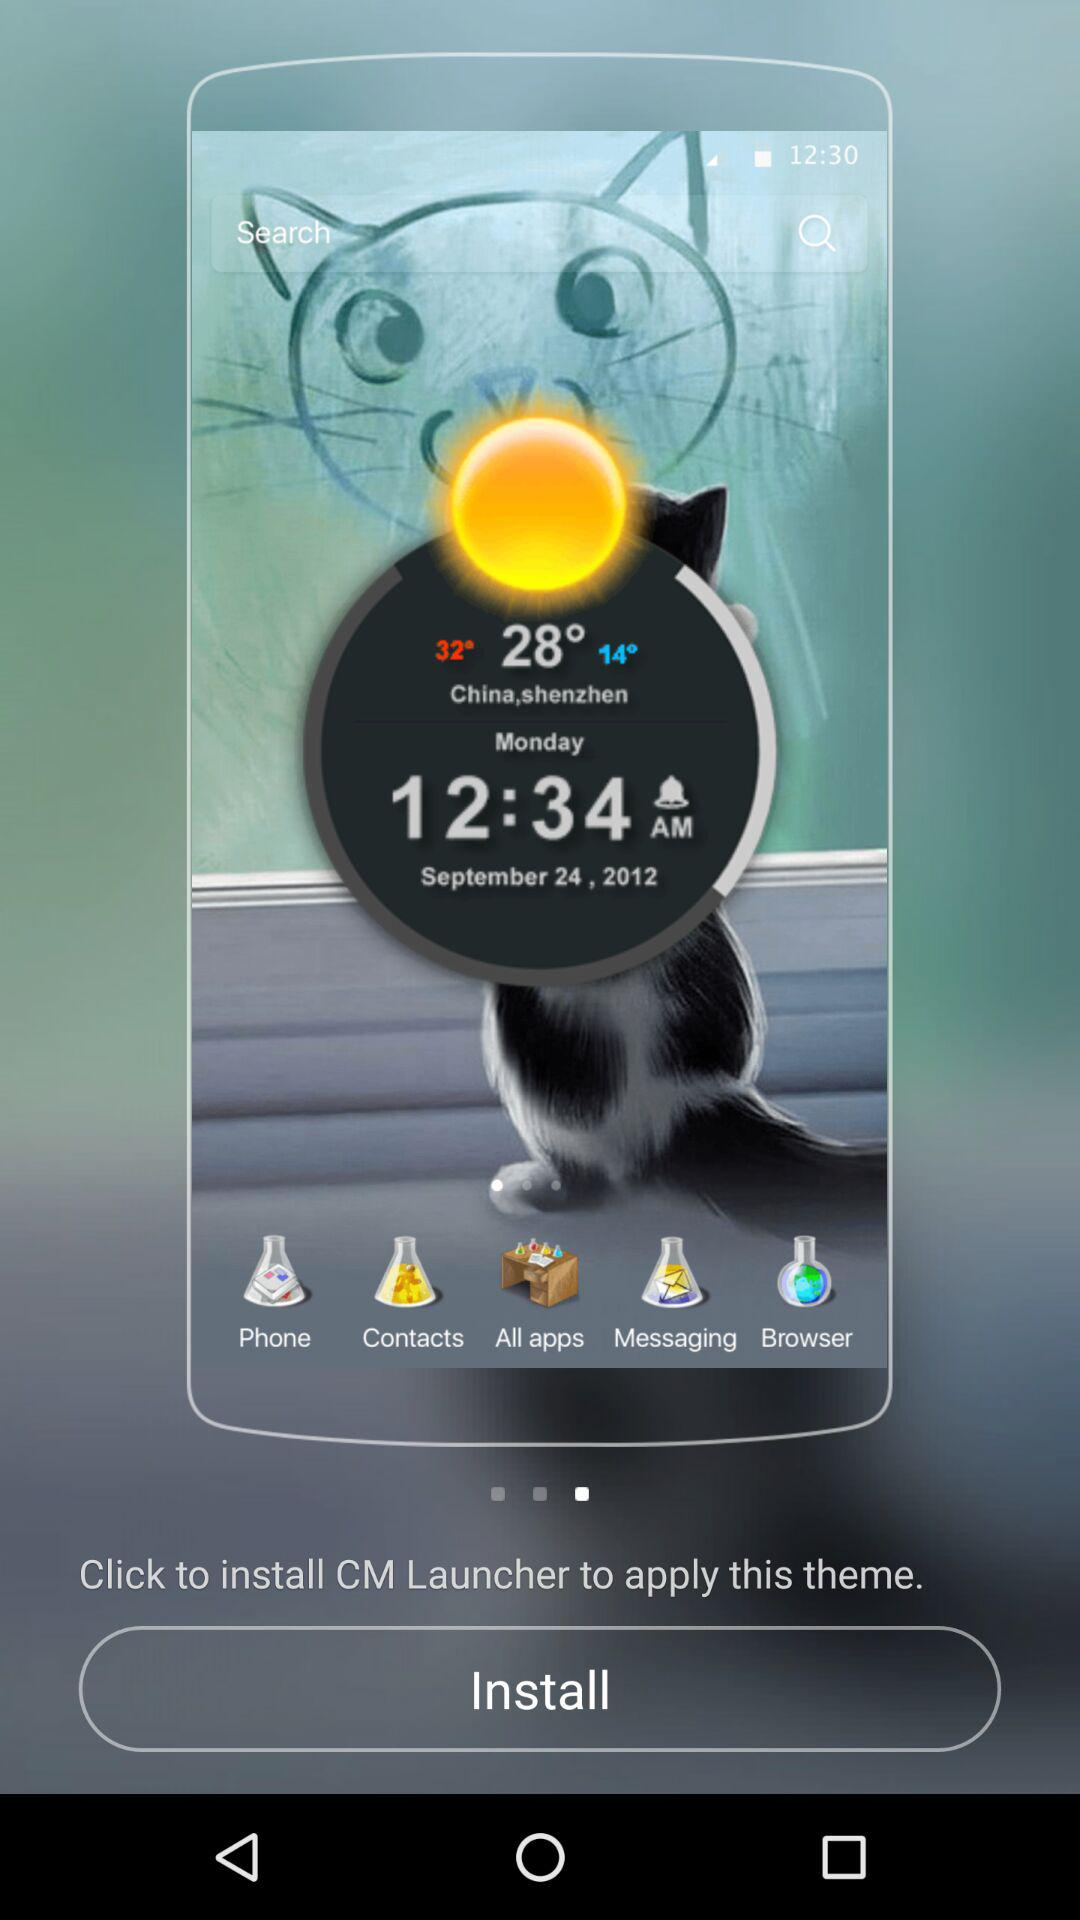What is the time? The time is 12:34 a.m. 